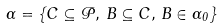Convert formula to latex. <formula><loc_0><loc_0><loc_500><loc_500>\Gamma = \{ C \subseteq \mathcal { P } , \, B \subseteq C , \, B \in \Gamma _ { 0 } \}</formula> 